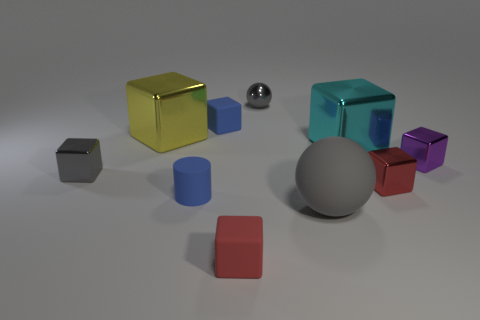Are there any big matte balls of the same color as the tiny sphere?
Give a very brief answer. Yes. Are any gray cubes visible?
Your response must be concise. Yes. Do the ball that is in front of the yellow metallic object and the blue cylinder have the same material?
Provide a short and direct response. Yes. There is a matte object that is the same color as the matte cylinder; what size is it?
Offer a very short reply. Small. What number of yellow metallic blocks are the same size as the gray rubber thing?
Ensure brevity in your answer.  1. Is the number of small purple objects to the right of the purple object the same as the number of rubber cylinders?
Your answer should be compact. No. What number of gray metal objects are on the right side of the small blue rubber block and in front of the large yellow shiny block?
Your answer should be compact. 0. What size is the yellow cube that is made of the same material as the small ball?
Offer a very short reply. Large. How many large yellow metallic objects have the same shape as the cyan object?
Ensure brevity in your answer.  1. Are there more small shiny cubes right of the red rubber object than small gray shiny balls?
Ensure brevity in your answer.  Yes. 